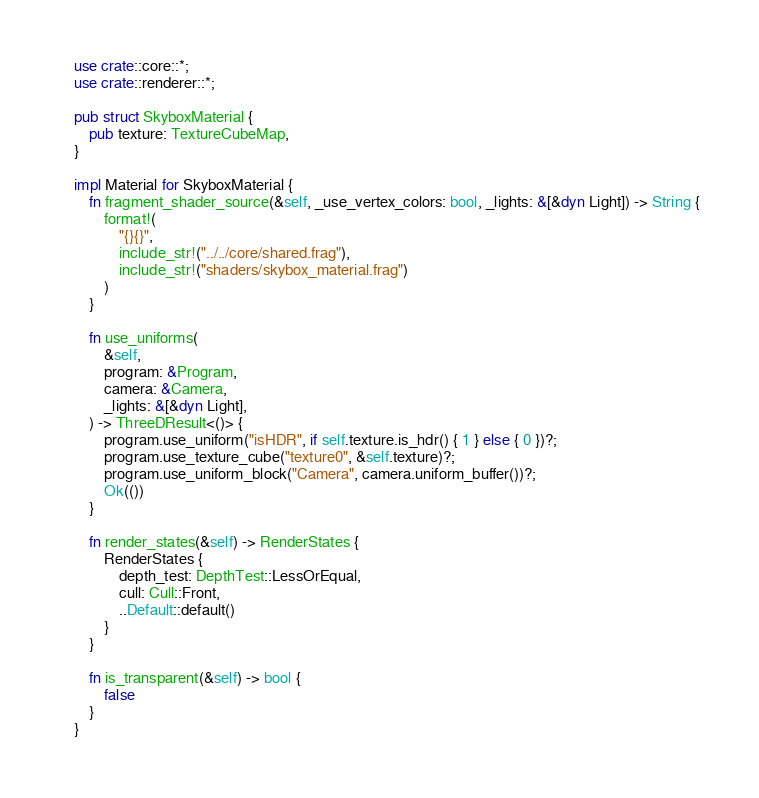Convert code to text. <code><loc_0><loc_0><loc_500><loc_500><_Rust_>use crate::core::*;
use crate::renderer::*;

pub struct SkyboxMaterial {
    pub texture: TextureCubeMap,
}

impl Material for SkyboxMaterial {
    fn fragment_shader_source(&self, _use_vertex_colors: bool, _lights: &[&dyn Light]) -> String {
        format!(
            "{}{}",
            include_str!("../../core/shared.frag"),
            include_str!("shaders/skybox_material.frag")
        )
    }

    fn use_uniforms(
        &self,
        program: &Program,
        camera: &Camera,
        _lights: &[&dyn Light],
    ) -> ThreeDResult<()> {
        program.use_uniform("isHDR", if self.texture.is_hdr() { 1 } else { 0 })?;
        program.use_texture_cube("texture0", &self.texture)?;
        program.use_uniform_block("Camera", camera.uniform_buffer())?;
        Ok(())
    }

    fn render_states(&self) -> RenderStates {
        RenderStates {
            depth_test: DepthTest::LessOrEqual,
            cull: Cull::Front,
            ..Default::default()
        }
    }

    fn is_transparent(&self) -> bool {
        false
    }
}
</code> 